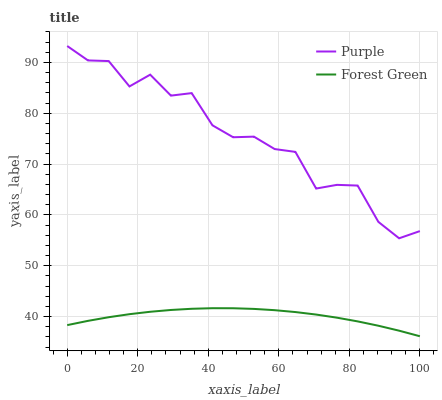Does Forest Green have the minimum area under the curve?
Answer yes or no. Yes. Does Purple have the maximum area under the curve?
Answer yes or no. Yes. Does Forest Green have the maximum area under the curve?
Answer yes or no. No. Is Forest Green the smoothest?
Answer yes or no. Yes. Is Purple the roughest?
Answer yes or no. Yes. Is Forest Green the roughest?
Answer yes or no. No. Does Forest Green have the lowest value?
Answer yes or no. Yes. Does Purple have the highest value?
Answer yes or no. Yes. Does Forest Green have the highest value?
Answer yes or no. No. Is Forest Green less than Purple?
Answer yes or no. Yes. Is Purple greater than Forest Green?
Answer yes or no. Yes. Does Forest Green intersect Purple?
Answer yes or no. No. 